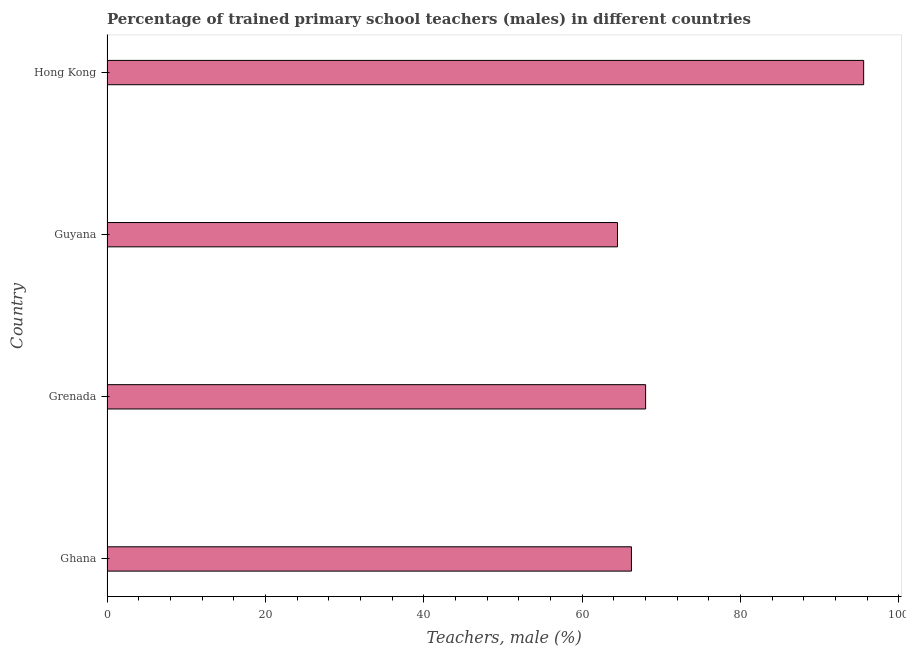Does the graph contain any zero values?
Your answer should be very brief. No. What is the title of the graph?
Make the answer very short. Percentage of trained primary school teachers (males) in different countries. What is the label or title of the X-axis?
Your answer should be compact. Teachers, male (%). What is the label or title of the Y-axis?
Provide a succinct answer. Country. What is the percentage of trained male teachers in Grenada?
Your answer should be very brief. 68.02. Across all countries, what is the maximum percentage of trained male teachers?
Offer a terse response. 95.56. Across all countries, what is the minimum percentage of trained male teachers?
Provide a short and direct response. 64.47. In which country was the percentage of trained male teachers maximum?
Ensure brevity in your answer.  Hong Kong. In which country was the percentage of trained male teachers minimum?
Keep it short and to the point. Guyana. What is the sum of the percentage of trained male teachers?
Provide a succinct answer. 294.29. What is the difference between the percentage of trained male teachers in Grenada and Hong Kong?
Give a very brief answer. -27.54. What is the average percentage of trained male teachers per country?
Ensure brevity in your answer.  73.57. What is the median percentage of trained male teachers?
Ensure brevity in your answer.  67.13. In how many countries, is the percentage of trained male teachers greater than 64 %?
Make the answer very short. 4. What is the ratio of the percentage of trained male teachers in Guyana to that in Hong Kong?
Your answer should be very brief. 0.68. What is the difference between the highest and the second highest percentage of trained male teachers?
Your answer should be compact. 27.54. What is the difference between the highest and the lowest percentage of trained male teachers?
Provide a short and direct response. 31.09. In how many countries, is the percentage of trained male teachers greater than the average percentage of trained male teachers taken over all countries?
Your answer should be very brief. 1. How many countries are there in the graph?
Offer a terse response. 4. What is the difference between two consecutive major ticks on the X-axis?
Keep it short and to the point. 20. What is the Teachers, male (%) in Ghana?
Your response must be concise. 66.23. What is the Teachers, male (%) in Grenada?
Your answer should be compact. 68.02. What is the Teachers, male (%) in Guyana?
Make the answer very short. 64.47. What is the Teachers, male (%) in Hong Kong?
Offer a very short reply. 95.56. What is the difference between the Teachers, male (%) in Ghana and Grenada?
Provide a short and direct response. -1.79. What is the difference between the Teachers, male (%) in Ghana and Guyana?
Your answer should be compact. 1.76. What is the difference between the Teachers, male (%) in Ghana and Hong Kong?
Give a very brief answer. -29.33. What is the difference between the Teachers, male (%) in Grenada and Guyana?
Your response must be concise. 3.55. What is the difference between the Teachers, male (%) in Grenada and Hong Kong?
Give a very brief answer. -27.54. What is the difference between the Teachers, male (%) in Guyana and Hong Kong?
Your answer should be compact. -31.09. What is the ratio of the Teachers, male (%) in Ghana to that in Grenada?
Your answer should be very brief. 0.97. What is the ratio of the Teachers, male (%) in Ghana to that in Guyana?
Provide a short and direct response. 1.03. What is the ratio of the Teachers, male (%) in Ghana to that in Hong Kong?
Make the answer very short. 0.69. What is the ratio of the Teachers, male (%) in Grenada to that in Guyana?
Keep it short and to the point. 1.05. What is the ratio of the Teachers, male (%) in Grenada to that in Hong Kong?
Offer a very short reply. 0.71. What is the ratio of the Teachers, male (%) in Guyana to that in Hong Kong?
Offer a terse response. 0.68. 